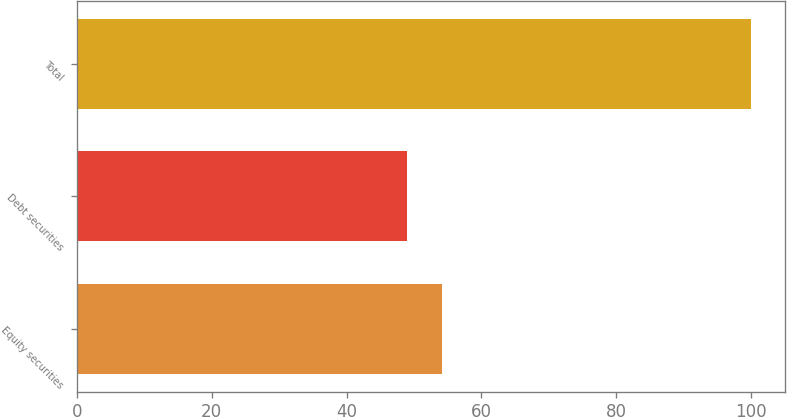<chart> <loc_0><loc_0><loc_500><loc_500><bar_chart><fcel>Equity securities<fcel>Debt securities<fcel>Total<nl><fcel>54.1<fcel>49<fcel>100<nl></chart> 